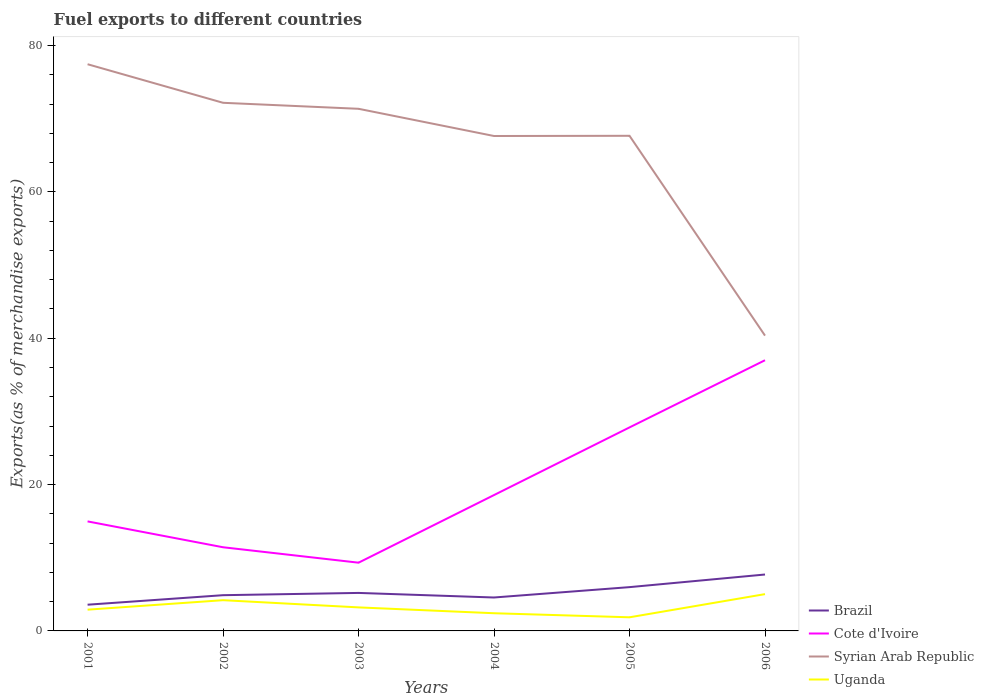Does the line corresponding to Uganda intersect with the line corresponding to Cote d'Ivoire?
Offer a terse response. No. Across all years, what is the maximum percentage of exports to different countries in Brazil?
Make the answer very short. 3.58. In which year was the percentage of exports to different countries in Uganda maximum?
Keep it short and to the point. 2005. What is the total percentage of exports to different countries in Uganda in the graph?
Make the answer very short. 1.04. What is the difference between the highest and the second highest percentage of exports to different countries in Brazil?
Offer a very short reply. 4.13. What is the difference between two consecutive major ticks on the Y-axis?
Keep it short and to the point. 20. Are the values on the major ticks of Y-axis written in scientific E-notation?
Ensure brevity in your answer.  No. Does the graph contain any zero values?
Offer a terse response. No. Where does the legend appear in the graph?
Your answer should be compact. Bottom right. What is the title of the graph?
Ensure brevity in your answer.  Fuel exports to different countries. What is the label or title of the X-axis?
Offer a terse response. Years. What is the label or title of the Y-axis?
Keep it short and to the point. Exports(as % of merchandise exports). What is the Exports(as % of merchandise exports) in Brazil in 2001?
Provide a short and direct response. 3.58. What is the Exports(as % of merchandise exports) of Cote d'Ivoire in 2001?
Provide a succinct answer. 14.97. What is the Exports(as % of merchandise exports) in Syrian Arab Republic in 2001?
Keep it short and to the point. 77.44. What is the Exports(as % of merchandise exports) of Uganda in 2001?
Ensure brevity in your answer.  2.9. What is the Exports(as % of merchandise exports) of Brazil in 2002?
Keep it short and to the point. 4.88. What is the Exports(as % of merchandise exports) of Cote d'Ivoire in 2002?
Provide a succinct answer. 11.43. What is the Exports(as % of merchandise exports) of Syrian Arab Republic in 2002?
Ensure brevity in your answer.  72.17. What is the Exports(as % of merchandise exports) in Uganda in 2002?
Offer a terse response. 4.2. What is the Exports(as % of merchandise exports) of Brazil in 2003?
Provide a succinct answer. 5.19. What is the Exports(as % of merchandise exports) in Cote d'Ivoire in 2003?
Your answer should be very brief. 9.33. What is the Exports(as % of merchandise exports) of Syrian Arab Republic in 2003?
Offer a very short reply. 71.35. What is the Exports(as % of merchandise exports) in Uganda in 2003?
Ensure brevity in your answer.  3.21. What is the Exports(as % of merchandise exports) of Brazil in 2004?
Offer a terse response. 4.57. What is the Exports(as % of merchandise exports) of Cote d'Ivoire in 2004?
Ensure brevity in your answer.  18.57. What is the Exports(as % of merchandise exports) of Syrian Arab Republic in 2004?
Provide a short and direct response. 67.63. What is the Exports(as % of merchandise exports) of Uganda in 2004?
Make the answer very short. 2.42. What is the Exports(as % of merchandise exports) in Brazil in 2005?
Make the answer very short. 5.98. What is the Exports(as % of merchandise exports) of Cote d'Ivoire in 2005?
Your response must be concise. 27.81. What is the Exports(as % of merchandise exports) in Syrian Arab Republic in 2005?
Your answer should be compact. 67.66. What is the Exports(as % of merchandise exports) in Uganda in 2005?
Give a very brief answer. 1.86. What is the Exports(as % of merchandise exports) of Brazil in 2006?
Provide a short and direct response. 7.71. What is the Exports(as % of merchandise exports) of Cote d'Ivoire in 2006?
Your response must be concise. 36.99. What is the Exports(as % of merchandise exports) of Syrian Arab Republic in 2006?
Keep it short and to the point. 40.35. What is the Exports(as % of merchandise exports) of Uganda in 2006?
Provide a short and direct response. 5.03. Across all years, what is the maximum Exports(as % of merchandise exports) of Brazil?
Ensure brevity in your answer.  7.71. Across all years, what is the maximum Exports(as % of merchandise exports) of Cote d'Ivoire?
Your answer should be very brief. 36.99. Across all years, what is the maximum Exports(as % of merchandise exports) in Syrian Arab Republic?
Make the answer very short. 77.44. Across all years, what is the maximum Exports(as % of merchandise exports) in Uganda?
Provide a succinct answer. 5.03. Across all years, what is the minimum Exports(as % of merchandise exports) of Brazil?
Give a very brief answer. 3.58. Across all years, what is the minimum Exports(as % of merchandise exports) of Cote d'Ivoire?
Make the answer very short. 9.33. Across all years, what is the minimum Exports(as % of merchandise exports) in Syrian Arab Republic?
Provide a succinct answer. 40.35. Across all years, what is the minimum Exports(as % of merchandise exports) of Uganda?
Provide a succinct answer. 1.86. What is the total Exports(as % of merchandise exports) of Brazil in the graph?
Ensure brevity in your answer.  31.92. What is the total Exports(as % of merchandise exports) in Cote d'Ivoire in the graph?
Your answer should be compact. 119.09. What is the total Exports(as % of merchandise exports) in Syrian Arab Republic in the graph?
Offer a very short reply. 396.59. What is the total Exports(as % of merchandise exports) in Uganda in the graph?
Ensure brevity in your answer.  19.63. What is the difference between the Exports(as % of merchandise exports) in Brazil in 2001 and that in 2002?
Your response must be concise. -1.3. What is the difference between the Exports(as % of merchandise exports) of Cote d'Ivoire in 2001 and that in 2002?
Make the answer very short. 3.53. What is the difference between the Exports(as % of merchandise exports) in Syrian Arab Republic in 2001 and that in 2002?
Offer a very short reply. 5.27. What is the difference between the Exports(as % of merchandise exports) of Uganda in 2001 and that in 2002?
Your answer should be compact. -1.3. What is the difference between the Exports(as % of merchandise exports) in Brazil in 2001 and that in 2003?
Provide a succinct answer. -1.61. What is the difference between the Exports(as % of merchandise exports) of Cote d'Ivoire in 2001 and that in 2003?
Provide a succinct answer. 5.64. What is the difference between the Exports(as % of merchandise exports) of Syrian Arab Republic in 2001 and that in 2003?
Your answer should be very brief. 6.09. What is the difference between the Exports(as % of merchandise exports) of Uganda in 2001 and that in 2003?
Your answer should be compact. -0.31. What is the difference between the Exports(as % of merchandise exports) of Brazil in 2001 and that in 2004?
Make the answer very short. -0.99. What is the difference between the Exports(as % of merchandise exports) in Cote d'Ivoire in 2001 and that in 2004?
Provide a short and direct response. -3.6. What is the difference between the Exports(as % of merchandise exports) of Syrian Arab Republic in 2001 and that in 2004?
Offer a terse response. 9.81. What is the difference between the Exports(as % of merchandise exports) of Uganda in 2001 and that in 2004?
Your response must be concise. 0.49. What is the difference between the Exports(as % of merchandise exports) in Brazil in 2001 and that in 2005?
Provide a short and direct response. -2.4. What is the difference between the Exports(as % of merchandise exports) of Cote d'Ivoire in 2001 and that in 2005?
Make the answer very short. -12.84. What is the difference between the Exports(as % of merchandise exports) of Syrian Arab Republic in 2001 and that in 2005?
Make the answer very short. 9.78. What is the difference between the Exports(as % of merchandise exports) of Uganda in 2001 and that in 2005?
Make the answer very short. 1.04. What is the difference between the Exports(as % of merchandise exports) in Brazil in 2001 and that in 2006?
Ensure brevity in your answer.  -4.13. What is the difference between the Exports(as % of merchandise exports) of Cote d'Ivoire in 2001 and that in 2006?
Your response must be concise. -22.02. What is the difference between the Exports(as % of merchandise exports) in Syrian Arab Republic in 2001 and that in 2006?
Your answer should be compact. 37.08. What is the difference between the Exports(as % of merchandise exports) in Uganda in 2001 and that in 2006?
Ensure brevity in your answer.  -2.12. What is the difference between the Exports(as % of merchandise exports) of Brazil in 2002 and that in 2003?
Your response must be concise. -0.31. What is the difference between the Exports(as % of merchandise exports) of Cote d'Ivoire in 2002 and that in 2003?
Your response must be concise. 2.11. What is the difference between the Exports(as % of merchandise exports) in Syrian Arab Republic in 2002 and that in 2003?
Provide a short and direct response. 0.82. What is the difference between the Exports(as % of merchandise exports) of Uganda in 2002 and that in 2003?
Make the answer very short. 0.99. What is the difference between the Exports(as % of merchandise exports) in Brazil in 2002 and that in 2004?
Provide a short and direct response. 0.32. What is the difference between the Exports(as % of merchandise exports) of Cote d'Ivoire in 2002 and that in 2004?
Provide a short and direct response. -7.13. What is the difference between the Exports(as % of merchandise exports) in Syrian Arab Republic in 2002 and that in 2004?
Make the answer very short. 4.54. What is the difference between the Exports(as % of merchandise exports) of Uganda in 2002 and that in 2004?
Provide a short and direct response. 1.78. What is the difference between the Exports(as % of merchandise exports) in Brazil in 2002 and that in 2005?
Offer a very short reply. -1.1. What is the difference between the Exports(as % of merchandise exports) of Cote d'Ivoire in 2002 and that in 2005?
Give a very brief answer. -16.38. What is the difference between the Exports(as % of merchandise exports) of Syrian Arab Republic in 2002 and that in 2005?
Ensure brevity in your answer.  4.51. What is the difference between the Exports(as % of merchandise exports) of Uganda in 2002 and that in 2005?
Provide a succinct answer. 2.34. What is the difference between the Exports(as % of merchandise exports) in Brazil in 2002 and that in 2006?
Ensure brevity in your answer.  -2.83. What is the difference between the Exports(as % of merchandise exports) of Cote d'Ivoire in 2002 and that in 2006?
Offer a very short reply. -25.56. What is the difference between the Exports(as % of merchandise exports) in Syrian Arab Republic in 2002 and that in 2006?
Ensure brevity in your answer.  31.81. What is the difference between the Exports(as % of merchandise exports) of Uganda in 2002 and that in 2006?
Provide a succinct answer. -0.83. What is the difference between the Exports(as % of merchandise exports) in Brazil in 2003 and that in 2004?
Your response must be concise. 0.63. What is the difference between the Exports(as % of merchandise exports) in Cote d'Ivoire in 2003 and that in 2004?
Offer a very short reply. -9.24. What is the difference between the Exports(as % of merchandise exports) of Syrian Arab Republic in 2003 and that in 2004?
Ensure brevity in your answer.  3.72. What is the difference between the Exports(as % of merchandise exports) in Uganda in 2003 and that in 2004?
Your answer should be compact. 0.8. What is the difference between the Exports(as % of merchandise exports) of Brazil in 2003 and that in 2005?
Your answer should be compact. -0.79. What is the difference between the Exports(as % of merchandise exports) in Cote d'Ivoire in 2003 and that in 2005?
Keep it short and to the point. -18.48. What is the difference between the Exports(as % of merchandise exports) of Syrian Arab Republic in 2003 and that in 2005?
Your response must be concise. 3.69. What is the difference between the Exports(as % of merchandise exports) in Uganda in 2003 and that in 2005?
Offer a terse response. 1.35. What is the difference between the Exports(as % of merchandise exports) in Brazil in 2003 and that in 2006?
Make the answer very short. -2.52. What is the difference between the Exports(as % of merchandise exports) in Cote d'Ivoire in 2003 and that in 2006?
Make the answer very short. -27.66. What is the difference between the Exports(as % of merchandise exports) of Syrian Arab Republic in 2003 and that in 2006?
Offer a very short reply. 30.99. What is the difference between the Exports(as % of merchandise exports) in Uganda in 2003 and that in 2006?
Give a very brief answer. -1.81. What is the difference between the Exports(as % of merchandise exports) of Brazil in 2004 and that in 2005?
Provide a succinct answer. -1.42. What is the difference between the Exports(as % of merchandise exports) in Cote d'Ivoire in 2004 and that in 2005?
Offer a very short reply. -9.24. What is the difference between the Exports(as % of merchandise exports) in Syrian Arab Republic in 2004 and that in 2005?
Provide a short and direct response. -0.03. What is the difference between the Exports(as % of merchandise exports) in Uganda in 2004 and that in 2005?
Give a very brief answer. 0.56. What is the difference between the Exports(as % of merchandise exports) in Brazil in 2004 and that in 2006?
Provide a succinct answer. -3.14. What is the difference between the Exports(as % of merchandise exports) of Cote d'Ivoire in 2004 and that in 2006?
Offer a very short reply. -18.42. What is the difference between the Exports(as % of merchandise exports) in Syrian Arab Republic in 2004 and that in 2006?
Ensure brevity in your answer.  27.27. What is the difference between the Exports(as % of merchandise exports) in Uganda in 2004 and that in 2006?
Give a very brief answer. -2.61. What is the difference between the Exports(as % of merchandise exports) in Brazil in 2005 and that in 2006?
Give a very brief answer. -1.73. What is the difference between the Exports(as % of merchandise exports) in Cote d'Ivoire in 2005 and that in 2006?
Offer a very short reply. -9.18. What is the difference between the Exports(as % of merchandise exports) of Syrian Arab Republic in 2005 and that in 2006?
Ensure brevity in your answer.  27.3. What is the difference between the Exports(as % of merchandise exports) in Uganda in 2005 and that in 2006?
Keep it short and to the point. -3.17. What is the difference between the Exports(as % of merchandise exports) of Brazil in 2001 and the Exports(as % of merchandise exports) of Cote d'Ivoire in 2002?
Offer a terse response. -7.85. What is the difference between the Exports(as % of merchandise exports) in Brazil in 2001 and the Exports(as % of merchandise exports) in Syrian Arab Republic in 2002?
Offer a very short reply. -68.58. What is the difference between the Exports(as % of merchandise exports) of Brazil in 2001 and the Exports(as % of merchandise exports) of Uganda in 2002?
Offer a terse response. -0.62. What is the difference between the Exports(as % of merchandise exports) in Cote d'Ivoire in 2001 and the Exports(as % of merchandise exports) in Syrian Arab Republic in 2002?
Offer a terse response. -57.2. What is the difference between the Exports(as % of merchandise exports) in Cote d'Ivoire in 2001 and the Exports(as % of merchandise exports) in Uganda in 2002?
Make the answer very short. 10.77. What is the difference between the Exports(as % of merchandise exports) in Syrian Arab Republic in 2001 and the Exports(as % of merchandise exports) in Uganda in 2002?
Ensure brevity in your answer.  73.24. What is the difference between the Exports(as % of merchandise exports) of Brazil in 2001 and the Exports(as % of merchandise exports) of Cote d'Ivoire in 2003?
Your answer should be compact. -5.74. What is the difference between the Exports(as % of merchandise exports) in Brazil in 2001 and the Exports(as % of merchandise exports) in Syrian Arab Republic in 2003?
Offer a terse response. -67.76. What is the difference between the Exports(as % of merchandise exports) in Brazil in 2001 and the Exports(as % of merchandise exports) in Uganda in 2003?
Your answer should be very brief. 0.37. What is the difference between the Exports(as % of merchandise exports) of Cote d'Ivoire in 2001 and the Exports(as % of merchandise exports) of Syrian Arab Republic in 2003?
Your answer should be compact. -56.38. What is the difference between the Exports(as % of merchandise exports) of Cote d'Ivoire in 2001 and the Exports(as % of merchandise exports) of Uganda in 2003?
Your answer should be compact. 11.75. What is the difference between the Exports(as % of merchandise exports) of Syrian Arab Republic in 2001 and the Exports(as % of merchandise exports) of Uganda in 2003?
Make the answer very short. 74.22. What is the difference between the Exports(as % of merchandise exports) in Brazil in 2001 and the Exports(as % of merchandise exports) in Cote d'Ivoire in 2004?
Offer a terse response. -14.98. What is the difference between the Exports(as % of merchandise exports) of Brazil in 2001 and the Exports(as % of merchandise exports) of Syrian Arab Republic in 2004?
Make the answer very short. -64.05. What is the difference between the Exports(as % of merchandise exports) of Brazil in 2001 and the Exports(as % of merchandise exports) of Uganda in 2004?
Your response must be concise. 1.17. What is the difference between the Exports(as % of merchandise exports) in Cote d'Ivoire in 2001 and the Exports(as % of merchandise exports) in Syrian Arab Republic in 2004?
Give a very brief answer. -52.66. What is the difference between the Exports(as % of merchandise exports) in Cote d'Ivoire in 2001 and the Exports(as % of merchandise exports) in Uganda in 2004?
Your answer should be very brief. 12.55. What is the difference between the Exports(as % of merchandise exports) in Syrian Arab Republic in 2001 and the Exports(as % of merchandise exports) in Uganda in 2004?
Provide a succinct answer. 75.02. What is the difference between the Exports(as % of merchandise exports) of Brazil in 2001 and the Exports(as % of merchandise exports) of Cote d'Ivoire in 2005?
Your answer should be compact. -24.23. What is the difference between the Exports(as % of merchandise exports) in Brazil in 2001 and the Exports(as % of merchandise exports) in Syrian Arab Republic in 2005?
Offer a very short reply. -64.07. What is the difference between the Exports(as % of merchandise exports) of Brazil in 2001 and the Exports(as % of merchandise exports) of Uganda in 2005?
Your answer should be compact. 1.72. What is the difference between the Exports(as % of merchandise exports) of Cote d'Ivoire in 2001 and the Exports(as % of merchandise exports) of Syrian Arab Republic in 2005?
Your response must be concise. -52.69. What is the difference between the Exports(as % of merchandise exports) in Cote d'Ivoire in 2001 and the Exports(as % of merchandise exports) in Uganda in 2005?
Offer a terse response. 13.1. What is the difference between the Exports(as % of merchandise exports) of Syrian Arab Republic in 2001 and the Exports(as % of merchandise exports) of Uganda in 2005?
Provide a short and direct response. 75.58. What is the difference between the Exports(as % of merchandise exports) of Brazil in 2001 and the Exports(as % of merchandise exports) of Cote d'Ivoire in 2006?
Make the answer very short. -33.41. What is the difference between the Exports(as % of merchandise exports) in Brazil in 2001 and the Exports(as % of merchandise exports) in Syrian Arab Republic in 2006?
Offer a terse response. -36.77. What is the difference between the Exports(as % of merchandise exports) in Brazil in 2001 and the Exports(as % of merchandise exports) in Uganda in 2006?
Offer a terse response. -1.45. What is the difference between the Exports(as % of merchandise exports) of Cote d'Ivoire in 2001 and the Exports(as % of merchandise exports) of Syrian Arab Republic in 2006?
Keep it short and to the point. -25.39. What is the difference between the Exports(as % of merchandise exports) of Cote d'Ivoire in 2001 and the Exports(as % of merchandise exports) of Uganda in 2006?
Give a very brief answer. 9.94. What is the difference between the Exports(as % of merchandise exports) in Syrian Arab Republic in 2001 and the Exports(as % of merchandise exports) in Uganda in 2006?
Make the answer very short. 72.41. What is the difference between the Exports(as % of merchandise exports) of Brazil in 2002 and the Exports(as % of merchandise exports) of Cote d'Ivoire in 2003?
Provide a short and direct response. -4.44. What is the difference between the Exports(as % of merchandise exports) in Brazil in 2002 and the Exports(as % of merchandise exports) in Syrian Arab Republic in 2003?
Your response must be concise. -66.46. What is the difference between the Exports(as % of merchandise exports) of Brazil in 2002 and the Exports(as % of merchandise exports) of Uganda in 2003?
Your answer should be very brief. 1.67. What is the difference between the Exports(as % of merchandise exports) of Cote d'Ivoire in 2002 and the Exports(as % of merchandise exports) of Syrian Arab Republic in 2003?
Offer a very short reply. -59.91. What is the difference between the Exports(as % of merchandise exports) in Cote d'Ivoire in 2002 and the Exports(as % of merchandise exports) in Uganda in 2003?
Keep it short and to the point. 8.22. What is the difference between the Exports(as % of merchandise exports) of Syrian Arab Republic in 2002 and the Exports(as % of merchandise exports) of Uganda in 2003?
Ensure brevity in your answer.  68.95. What is the difference between the Exports(as % of merchandise exports) of Brazil in 2002 and the Exports(as % of merchandise exports) of Cote d'Ivoire in 2004?
Ensure brevity in your answer.  -13.68. What is the difference between the Exports(as % of merchandise exports) in Brazil in 2002 and the Exports(as % of merchandise exports) in Syrian Arab Republic in 2004?
Keep it short and to the point. -62.75. What is the difference between the Exports(as % of merchandise exports) of Brazil in 2002 and the Exports(as % of merchandise exports) of Uganda in 2004?
Give a very brief answer. 2.47. What is the difference between the Exports(as % of merchandise exports) of Cote d'Ivoire in 2002 and the Exports(as % of merchandise exports) of Syrian Arab Republic in 2004?
Keep it short and to the point. -56.2. What is the difference between the Exports(as % of merchandise exports) in Cote d'Ivoire in 2002 and the Exports(as % of merchandise exports) in Uganda in 2004?
Your answer should be compact. 9.02. What is the difference between the Exports(as % of merchandise exports) of Syrian Arab Republic in 2002 and the Exports(as % of merchandise exports) of Uganda in 2004?
Your answer should be very brief. 69.75. What is the difference between the Exports(as % of merchandise exports) of Brazil in 2002 and the Exports(as % of merchandise exports) of Cote d'Ivoire in 2005?
Offer a very short reply. -22.93. What is the difference between the Exports(as % of merchandise exports) of Brazil in 2002 and the Exports(as % of merchandise exports) of Syrian Arab Republic in 2005?
Give a very brief answer. -62.77. What is the difference between the Exports(as % of merchandise exports) of Brazil in 2002 and the Exports(as % of merchandise exports) of Uganda in 2005?
Your answer should be compact. 3.02. What is the difference between the Exports(as % of merchandise exports) in Cote d'Ivoire in 2002 and the Exports(as % of merchandise exports) in Syrian Arab Republic in 2005?
Make the answer very short. -56.22. What is the difference between the Exports(as % of merchandise exports) in Cote d'Ivoire in 2002 and the Exports(as % of merchandise exports) in Uganda in 2005?
Your answer should be compact. 9.57. What is the difference between the Exports(as % of merchandise exports) of Syrian Arab Republic in 2002 and the Exports(as % of merchandise exports) of Uganda in 2005?
Keep it short and to the point. 70.31. What is the difference between the Exports(as % of merchandise exports) of Brazil in 2002 and the Exports(as % of merchandise exports) of Cote d'Ivoire in 2006?
Give a very brief answer. -32.11. What is the difference between the Exports(as % of merchandise exports) of Brazil in 2002 and the Exports(as % of merchandise exports) of Syrian Arab Republic in 2006?
Your response must be concise. -35.47. What is the difference between the Exports(as % of merchandise exports) in Brazil in 2002 and the Exports(as % of merchandise exports) in Uganda in 2006?
Make the answer very short. -0.14. What is the difference between the Exports(as % of merchandise exports) of Cote d'Ivoire in 2002 and the Exports(as % of merchandise exports) of Syrian Arab Republic in 2006?
Your response must be concise. -28.92. What is the difference between the Exports(as % of merchandise exports) in Cote d'Ivoire in 2002 and the Exports(as % of merchandise exports) in Uganda in 2006?
Ensure brevity in your answer.  6.4. What is the difference between the Exports(as % of merchandise exports) in Syrian Arab Republic in 2002 and the Exports(as % of merchandise exports) in Uganda in 2006?
Your answer should be compact. 67.14. What is the difference between the Exports(as % of merchandise exports) in Brazil in 2003 and the Exports(as % of merchandise exports) in Cote d'Ivoire in 2004?
Your answer should be very brief. -13.37. What is the difference between the Exports(as % of merchandise exports) of Brazil in 2003 and the Exports(as % of merchandise exports) of Syrian Arab Republic in 2004?
Make the answer very short. -62.44. What is the difference between the Exports(as % of merchandise exports) in Brazil in 2003 and the Exports(as % of merchandise exports) in Uganda in 2004?
Give a very brief answer. 2.78. What is the difference between the Exports(as % of merchandise exports) in Cote d'Ivoire in 2003 and the Exports(as % of merchandise exports) in Syrian Arab Republic in 2004?
Provide a succinct answer. -58.3. What is the difference between the Exports(as % of merchandise exports) of Cote d'Ivoire in 2003 and the Exports(as % of merchandise exports) of Uganda in 2004?
Keep it short and to the point. 6.91. What is the difference between the Exports(as % of merchandise exports) of Syrian Arab Republic in 2003 and the Exports(as % of merchandise exports) of Uganda in 2004?
Offer a very short reply. 68.93. What is the difference between the Exports(as % of merchandise exports) of Brazil in 2003 and the Exports(as % of merchandise exports) of Cote d'Ivoire in 2005?
Provide a short and direct response. -22.62. What is the difference between the Exports(as % of merchandise exports) in Brazil in 2003 and the Exports(as % of merchandise exports) in Syrian Arab Republic in 2005?
Give a very brief answer. -62.46. What is the difference between the Exports(as % of merchandise exports) of Brazil in 2003 and the Exports(as % of merchandise exports) of Uganda in 2005?
Offer a terse response. 3.33. What is the difference between the Exports(as % of merchandise exports) in Cote d'Ivoire in 2003 and the Exports(as % of merchandise exports) in Syrian Arab Republic in 2005?
Keep it short and to the point. -58.33. What is the difference between the Exports(as % of merchandise exports) in Cote d'Ivoire in 2003 and the Exports(as % of merchandise exports) in Uganda in 2005?
Offer a terse response. 7.46. What is the difference between the Exports(as % of merchandise exports) in Syrian Arab Republic in 2003 and the Exports(as % of merchandise exports) in Uganda in 2005?
Your response must be concise. 69.49. What is the difference between the Exports(as % of merchandise exports) in Brazil in 2003 and the Exports(as % of merchandise exports) in Cote d'Ivoire in 2006?
Ensure brevity in your answer.  -31.8. What is the difference between the Exports(as % of merchandise exports) in Brazil in 2003 and the Exports(as % of merchandise exports) in Syrian Arab Republic in 2006?
Keep it short and to the point. -35.16. What is the difference between the Exports(as % of merchandise exports) in Brazil in 2003 and the Exports(as % of merchandise exports) in Uganda in 2006?
Your response must be concise. 0.16. What is the difference between the Exports(as % of merchandise exports) in Cote d'Ivoire in 2003 and the Exports(as % of merchandise exports) in Syrian Arab Republic in 2006?
Give a very brief answer. -31.03. What is the difference between the Exports(as % of merchandise exports) in Cote d'Ivoire in 2003 and the Exports(as % of merchandise exports) in Uganda in 2006?
Ensure brevity in your answer.  4.3. What is the difference between the Exports(as % of merchandise exports) in Syrian Arab Republic in 2003 and the Exports(as % of merchandise exports) in Uganda in 2006?
Your response must be concise. 66.32. What is the difference between the Exports(as % of merchandise exports) in Brazil in 2004 and the Exports(as % of merchandise exports) in Cote d'Ivoire in 2005?
Keep it short and to the point. -23.24. What is the difference between the Exports(as % of merchandise exports) of Brazil in 2004 and the Exports(as % of merchandise exports) of Syrian Arab Republic in 2005?
Offer a very short reply. -63.09. What is the difference between the Exports(as % of merchandise exports) of Brazil in 2004 and the Exports(as % of merchandise exports) of Uganda in 2005?
Provide a short and direct response. 2.71. What is the difference between the Exports(as % of merchandise exports) in Cote d'Ivoire in 2004 and the Exports(as % of merchandise exports) in Syrian Arab Republic in 2005?
Make the answer very short. -49.09. What is the difference between the Exports(as % of merchandise exports) in Cote d'Ivoire in 2004 and the Exports(as % of merchandise exports) in Uganda in 2005?
Provide a short and direct response. 16.71. What is the difference between the Exports(as % of merchandise exports) in Syrian Arab Republic in 2004 and the Exports(as % of merchandise exports) in Uganda in 2005?
Keep it short and to the point. 65.77. What is the difference between the Exports(as % of merchandise exports) in Brazil in 2004 and the Exports(as % of merchandise exports) in Cote d'Ivoire in 2006?
Your response must be concise. -32.42. What is the difference between the Exports(as % of merchandise exports) of Brazil in 2004 and the Exports(as % of merchandise exports) of Syrian Arab Republic in 2006?
Ensure brevity in your answer.  -35.79. What is the difference between the Exports(as % of merchandise exports) of Brazil in 2004 and the Exports(as % of merchandise exports) of Uganda in 2006?
Ensure brevity in your answer.  -0.46. What is the difference between the Exports(as % of merchandise exports) of Cote d'Ivoire in 2004 and the Exports(as % of merchandise exports) of Syrian Arab Republic in 2006?
Give a very brief answer. -21.79. What is the difference between the Exports(as % of merchandise exports) of Cote d'Ivoire in 2004 and the Exports(as % of merchandise exports) of Uganda in 2006?
Your answer should be compact. 13.54. What is the difference between the Exports(as % of merchandise exports) of Syrian Arab Republic in 2004 and the Exports(as % of merchandise exports) of Uganda in 2006?
Make the answer very short. 62.6. What is the difference between the Exports(as % of merchandise exports) in Brazil in 2005 and the Exports(as % of merchandise exports) in Cote d'Ivoire in 2006?
Keep it short and to the point. -31.01. What is the difference between the Exports(as % of merchandise exports) in Brazil in 2005 and the Exports(as % of merchandise exports) in Syrian Arab Republic in 2006?
Give a very brief answer. -34.37. What is the difference between the Exports(as % of merchandise exports) of Brazil in 2005 and the Exports(as % of merchandise exports) of Uganda in 2006?
Provide a short and direct response. 0.95. What is the difference between the Exports(as % of merchandise exports) in Cote d'Ivoire in 2005 and the Exports(as % of merchandise exports) in Syrian Arab Republic in 2006?
Provide a short and direct response. -12.54. What is the difference between the Exports(as % of merchandise exports) of Cote d'Ivoire in 2005 and the Exports(as % of merchandise exports) of Uganda in 2006?
Your answer should be compact. 22.78. What is the difference between the Exports(as % of merchandise exports) of Syrian Arab Republic in 2005 and the Exports(as % of merchandise exports) of Uganda in 2006?
Offer a very short reply. 62.63. What is the average Exports(as % of merchandise exports) in Brazil per year?
Offer a terse response. 5.32. What is the average Exports(as % of merchandise exports) of Cote d'Ivoire per year?
Offer a terse response. 19.85. What is the average Exports(as % of merchandise exports) in Syrian Arab Republic per year?
Your answer should be very brief. 66.1. What is the average Exports(as % of merchandise exports) of Uganda per year?
Provide a succinct answer. 3.27. In the year 2001, what is the difference between the Exports(as % of merchandise exports) of Brazil and Exports(as % of merchandise exports) of Cote d'Ivoire?
Offer a terse response. -11.38. In the year 2001, what is the difference between the Exports(as % of merchandise exports) of Brazil and Exports(as % of merchandise exports) of Syrian Arab Republic?
Offer a very short reply. -73.85. In the year 2001, what is the difference between the Exports(as % of merchandise exports) in Brazil and Exports(as % of merchandise exports) in Uganda?
Your answer should be compact. 0.68. In the year 2001, what is the difference between the Exports(as % of merchandise exports) of Cote d'Ivoire and Exports(as % of merchandise exports) of Syrian Arab Republic?
Provide a succinct answer. -62.47. In the year 2001, what is the difference between the Exports(as % of merchandise exports) of Cote d'Ivoire and Exports(as % of merchandise exports) of Uganda?
Offer a very short reply. 12.06. In the year 2001, what is the difference between the Exports(as % of merchandise exports) in Syrian Arab Republic and Exports(as % of merchandise exports) in Uganda?
Give a very brief answer. 74.53. In the year 2002, what is the difference between the Exports(as % of merchandise exports) in Brazil and Exports(as % of merchandise exports) in Cote d'Ivoire?
Your response must be concise. -6.55. In the year 2002, what is the difference between the Exports(as % of merchandise exports) in Brazil and Exports(as % of merchandise exports) in Syrian Arab Republic?
Your answer should be compact. -67.28. In the year 2002, what is the difference between the Exports(as % of merchandise exports) in Brazil and Exports(as % of merchandise exports) in Uganda?
Your response must be concise. 0.68. In the year 2002, what is the difference between the Exports(as % of merchandise exports) of Cote d'Ivoire and Exports(as % of merchandise exports) of Syrian Arab Republic?
Provide a short and direct response. -60.73. In the year 2002, what is the difference between the Exports(as % of merchandise exports) in Cote d'Ivoire and Exports(as % of merchandise exports) in Uganda?
Keep it short and to the point. 7.23. In the year 2002, what is the difference between the Exports(as % of merchandise exports) of Syrian Arab Republic and Exports(as % of merchandise exports) of Uganda?
Keep it short and to the point. 67.97. In the year 2003, what is the difference between the Exports(as % of merchandise exports) of Brazil and Exports(as % of merchandise exports) of Cote d'Ivoire?
Your response must be concise. -4.13. In the year 2003, what is the difference between the Exports(as % of merchandise exports) in Brazil and Exports(as % of merchandise exports) in Syrian Arab Republic?
Ensure brevity in your answer.  -66.15. In the year 2003, what is the difference between the Exports(as % of merchandise exports) in Brazil and Exports(as % of merchandise exports) in Uganda?
Provide a short and direct response. 1.98. In the year 2003, what is the difference between the Exports(as % of merchandise exports) of Cote d'Ivoire and Exports(as % of merchandise exports) of Syrian Arab Republic?
Make the answer very short. -62.02. In the year 2003, what is the difference between the Exports(as % of merchandise exports) in Cote d'Ivoire and Exports(as % of merchandise exports) in Uganda?
Make the answer very short. 6.11. In the year 2003, what is the difference between the Exports(as % of merchandise exports) of Syrian Arab Republic and Exports(as % of merchandise exports) of Uganda?
Make the answer very short. 68.13. In the year 2004, what is the difference between the Exports(as % of merchandise exports) of Brazil and Exports(as % of merchandise exports) of Cote d'Ivoire?
Provide a succinct answer. -14. In the year 2004, what is the difference between the Exports(as % of merchandise exports) in Brazil and Exports(as % of merchandise exports) in Syrian Arab Republic?
Keep it short and to the point. -63.06. In the year 2004, what is the difference between the Exports(as % of merchandise exports) of Brazil and Exports(as % of merchandise exports) of Uganda?
Provide a succinct answer. 2.15. In the year 2004, what is the difference between the Exports(as % of merchandise exports) of Cote d'Ivoire and Exports(as % of merchandise exports) of Syrian Arab Republic?
Make the answer very short. -49.06. In the year 2004, what is the difference between the Exports(as % of merchandise exports) of Cote d'Ivoire and Exports(as % of merchandise exports) of Uganda?
Keep it short and to the point. 16.15. In the year 2004, what is the difference between the Exports(as % of merchandise exports) of Syrian Arab Republic and Exports(as % of merchandise exports) of Uganda?
Offer a terse response. 65.21. In the year 2005, what is the difference between the Exports(as % of merchandise exports) in Brazil and Exports(as % of merchandise exports) in Cote d'Ivoire?
Ensure brevity in your answer.  -21.83. In the year 2005, what is the difference between the Exports(as % of merchandise exports) in Brazil and Exports(as % of merchandise exports) in Syrian Arab Republic?
Offer a very short reply. -61.67. In the year 2005, what is the difference between the Exports(as % of merchandise exports) of Brazil and Exports(as % of merchandise exports) of Uganda?
Give a very brief answer. 4.12. In the year 2005, what is the difference between the Exports(as % of merchandise exports) of Cote d'Ivoire and Exports(as % of merchandise exports) of Syrian Arab Republic?
Give a very brief answer. -39.85. In the year 2005, what is the difference between the Exports(as % of merchandise exports) in Cote d'Ivoire and Exports(as % of merchandise exports) in Uganda?
Offer a terse response. 25.95. In the year 2005, what is the difference between the Exports(as % of merchandise exports) in Syrian Arab Republic and Exports(as % of merchandise exports) in Uganda?
Ensure brevity in your answer.  65.8. In the year 2006, what is the difference between the Exports(as % of merchandise exports) in Brazil and Exports(as % of merchandise exports) in Cote d'Ivoire?
Keep it short and to the point. -29.28. In the year 2006, what is the difference between the Exports(as % of merchandise exports) in Brazil and Exports(as % of merchandise exports) in Syrian Arab Republic?
Ensure brevity in your answer.  -32.65. In the year 2006, what is the difference between the Exports(as % of merchandise exports) in Brazil and Exports(as % of merchandise exports) in Uganda?
Your answer should be compact. 2.68. In the year 2006, what is the difference between the Exports(as % of merchandise exports) of Cote d'Ivoire and Exports(as % of merchandise exports) of Syrian Arab Republic?
Make the answer very short. -3.37. In the year 2006, what is the difference between the Exports(as % of merchandise exports) of Cote d'Ivoire and Exports(as % of merchandise exports) of Uganda?
Make the answer very short. 31.96. In the year 2006, what is the difference between the Exports(as % of merchandise exports) of Syrian Arab Republic and Exports(as % of merchandise exports) of Uganda?
Your answer should be very brief. 35.33. What is the ratio of the Exports(as % of merchandise exports) of Brazil in 2001 to that in 2002?
Your answer should be very brief. 0.73. What is the ratio of the Exports(as % of merchandise exports) in Cote d'Ivoire in 2001 to that in 2002?
Provide a succinct answer. 1.31. What is the ratio of the Exports(as % of merchandise exports) of Syrian Arab Republic in 2001 to that in 2002?
Your answer should be compact. 1.07. What is the ratio of the Exports(as % of merchandise exports) in Uganda in 2001 to that in 2002?
Your answer should be very brief. 0.69. What is the ratio of the Exports(as % of merchandise exports) in Brazil in 2001 to that in 2003?
Make the answer very short. 0.69. What is the ratio of the Exports(as % of merchandise exports) of Cote d'Ivoire in 2001 to that in 2003?
Provide a succinct answer. 1.6. What is the ratio of the Exports(as % of merchandise exports) in Syrian Arab Republic in 2001 to that in 2003?
Provide a short and direct response. 1.09. What is the ratio of the Exports(as % of merchandise exports) of Uganda in 2001 to that in 2003?
Offer a terse response. 0.9. What is the ratio of the Exports(as % of merchandise exports) in Brazil in 2001 to that in 2004?
Keep it short and to the point. 0.78. What is the ratio of the Exports(as % of merchandise exports) of Cote d'Ivoire in 2001 to that in 2004?
Provide a succinct answer. 0.81. What is the ratio of the Exports(as % of merchandise exports) in Syrian Arab Republic in 2001 to that in 2004?
Keep it short and to the point. 1.15. What is the ratio of the Exports(as % of merchandise exports) of Uganda in 2001 to that in 2004?
Offer a very short reply. 1.2. What is the ratio of the Exports(as % of merchandise exports) of Brazil in 2001 to that in 2005?
Offer a very short reply. 0.6. What is the ratio of the Exports(as % of merchandise exports) of Cote d'Ivoire in 2001 to that in 2005?
Your response must be concise. 0.54. What is the ratio of the Exports(as % of merchandise exports) of Syrian Arab Republic in 2001 to that in 2005?
Give a very brief answer. 1.14. What is the ratio of the Exports(as % of merchandise exports) in Uganda in 2001 to that in 2005?
Your answer should be very brief. 1.56. What is the ratio of the Exports(as % of merchandise exports) in Brazil in 2001 to that in 2006?
Make the answer very short. 0.46. What is the ratio of the Exports(as % of merchandise exports) in Cote d'Ivoire in 2001 to that in 2006?
Offer a terse response. 0.4. What is the ratio of the Exports(as % of merchandise exports) of Syrian Arab Republic in 2001 to that in 2006?
Give a very brief answer. 1.92. What is the ratio of the Exports(as % of merchandise exports) of Uganda in 2001 to that in 2006?
Provide a short and direct response. 0.58. What is the ratio of the Exports(as % of merchandise exports) in Brazil in 2002 to that in 2003?
Provide a short and direct response. 0.94. What is the ratio of the Exports(as % of merchandise exports) in Cote d'Ivoire in 2002 to that in 2003?
Your answer should be very brief. 1.23. What is the ratio of the Exports(as % of merchandise exports) in Syrian Arab Republic in 2002 to that in 2003?
Your response must be concise. 1.01. What is the ratio of the Exports(as % of merchandise exports) in Uganda in 2002 to that in 2003?
Make the answer very short. 1.31. What is the ratio of the Exports(as % of merchandise exports) of Brazil in 2002 to that in 2004?
Offer a terse response. 1.07. What is the ratio of the Exports(as % of merchandise exports) in Cote d'Ivoire in 2002 to that in 2004?
Ensure brevity in your answer.  0.62. What is the ratio of the Exports(as % of merchandise exports) in Syrian Arab Republic in 2002 to that in 2004?
Offer a terse response. 1.07. What is the ratio of the Exports(as % of merchandise exports) in Uganda in 2002 to that in 2004?
Ensure brevity in your answer.  1.74. What is the ratio of the Exports(as % of merchandise exports) of Brazil in 2002 to that in 2005?
Offer a terse response. 0.82. What is the ratio of the Exports(as % of merchandise exports) of Cote d'Ivoire in 2002 to that in 2005?
Make the answer very short. 0.41. What is the ratio of the Exports(as % of merchandise exports) of Syrian Arab Republic in 2002 to that in 2005?
Your answer should be compact. 1.07. What is the ratio of the Exports(as % of merchandise exports) in Uganda in 2002 to that in 2005?
Your response must be concise. 2.26. What is the ratio of the Exports(as % of merchandise exports) in Brazil in 2002 to that in 2006?
Offer a very short reply. 0.63. What is the ratio of the Exports(as % of merchandise exports) in Cote d'Ivoire in 2002 to that in 2006?
Your response must be concise. 0.31. What is the ratio of the Exports(as % of merchandise exports) of Syrian Arab Republic in 2002 to that in 2006?
Your answer should be compact. 1.79. What is the ratio of the Exports(as % of merchandise exports) in Uganda in 2002 to that in 2006?
Your response must be concise. 0.84. What is the ratio of the Exports(as % of merchandise exports) of Brazil in 2003 to that in 2004?
Provide a succinct answer. 1.14. What is the ratio of the Exports(as % of merchandise exports) in Cote d'Ivoire in 2003 to that in 2004?
Provide a succinct answer. 0.5. What is the ratio of the Exports(as % of merchandise exports) of Syrian Arab Republic in 2003 to that in 2004?
Keep it short and to the point. 1.05. What is the ratio of the Exports(as % of merchandise exports) in Uganda in 2003 to that in 2004?
Your answer should be very brief. 1.33. What is the ratio of the Exports(as % of merchandise exports) in Brazil in 2003 to that in 2005?
Give a very brief answer. 0.87. What is the ratio of the Exports(as % of merchandise exports) in Cote d'Ivoire in 2003 to that in 2005?
Keep it short and to the point. 0.34. What is the ratio of the Exports(as % of merchandise exports) in Syrian Arab Republic in 2003 to that in 2005?
Your answer should be compact. 1.05. What is the ratio of the Exports(as % of merchandise exports) of Uganda in 2003 to that in 2005?
Keep it short and to the point. 1.73. What is the ratio of the Exports(as % of merchandise exports) of Brazil in 2003 to that in 2006?
Provide a succinct answer. 0.67. What is the ratio of the Exports(as % of merchandise exports) of Cote d'Ivoire in 2003 to that in 2006?
Your answer should be compact. 0.25. What is the ratio of the Exports(as % of merchandise exports) of Syrian Arab Republic in 2003 to that in 2006?
Your response must be concise. 1.77. What is the ratio of the Exports(as % of merchandise exports) of Uganda in 2003 to that in 2006?
Make the answer very short. 0.64. What is the ratio of the Exports(as % of merchandise exports) of Brazil in 2004 to that in 2005?
Make the answer very short. 0.76. What is the ratio of the Exports(as % of merchandise exports) of Cote d'Ivoire in 2004 to that in 2005?
Keep it short and to the point. 0.67. What is the ratio of the Exports(as % of merchandise exports) of Syrian Arab Republic in 2004 to that in 2005?
Make the answer very short. 1. What is the ratio of the Exports(as % of merchandise exports) of Uganda in 2004 to that in 2005?
Offer a terse response. 1.3. What is the ratio of the Exports(as % of merchandise exports) of Brazil in 2004 to that in 2006?
Offer a very short reply. 0.59. What is the ratio of the Exports(as % of merchandise exports) of Cote d'Ivoire in 2004 to that in 2006?
Your response must be concise. 0.5. What is the ratio of the Exports(as % of merchandise exports) in Syrian Arab Republic in 2004 to that in 2006?
Ensure brevity in your answer.  1.68. What is the ratio of the Exports(as % of merchandise exports) in Uganda in 2004 to that in 2006?
Your answer should be very brief. 0.48. What is the ratio of the Exports(as % of merchandise exports) in Brazil in 2005 to that in 2006?
Ensure brevity in your answer.  0.78. What is the ratio of the Exports(as % of merchandise exports) in Cote d'Ivoire in 2005 to that in 2006?
Your answer should be very brief. 0.75. What is the ratio of the Exports(as % of merchandise exports) in Syrian Arab Republic in 2005 to that in 2006?
Your response must be concise. 1.68. What is the ratio of the Exports(as % of merchandise exports) of Uganda in 2005 to that in 2006?
Offer a very short reply. 0.37. What is the difference between the highest and the second highest Exports(as % of merchandise exports) in Brazil?
Offer a very short reply. 1.73. What is the difference between the highest and the second highest Exports(as % of merchandise exports) in Cote d'Ivoire?
Make the answer very short. 9.18. What is the difference between the highest and the second highest Exports(as % of merchandise exports) of Syrian Arab Republic?
Your answer should be compact. 5.27. What is the difference between the highest and the second highest Exports(as % of merchandise exports) in Uganda?
Offer a very short reply. 0.83. What is the difference between the highest and the lowest Exports(as % of merchandise exports) of Brazil?
Make the answer very short. 4.13. What is the difference between the highest and the lowest Exports(as % of merchandise exports) in Cote d'Ivoire?
Your response must be concise. 27.66. What is the difference between the highest and the lowest Exports(as % of merchandise exports) in Syrian Arab Republic?
Offer a very short reply. 37.08. What is the difference between the highest and the lowest Exports(as % of merchandise exports) of Uganda?
Offer a very short reply. 3.17. 